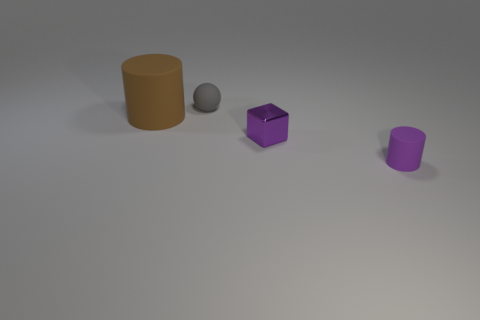How many things are small objects in front of the tiny gray rubber sphere or cylinders on the left side of the tiny metallic object?
Your response must be concise. 3. How many matte cylinders are to the left of the rubber cylinder on the right side of the gray object?
Provide a succinct answer. 1. There is a object that is behind the large brown matte object; does it have the same shape as the purple object behind the tiny purple cylinder?
Offer a terse response. No. What shape is the tiny rubber object that is the same color as the shiny block?
Make the answer very short. Cylinder. Is there a big brown sphere that has the same material as the small purple block?
Keep it short and to the point. No. How many metal things are either tiny gray cubes or purple cubes?
Ensure brevity in your answer.  1. There is a small purple object that is behind the tiny matte object in front of the tiny ball; what is its shape?
Make the answer very short. Cube. Is the number of blocks that are on the right side of the small shiny cube less than the number of tiny purple blocks?
Keep it short and to the point. Yes. The tiny purple rubber object is what shape?
Keep it short and to the point. Cylinder. What size is the rubber cylinder on the left side of the tiny cylinder?
Provide a short and direct response. Large. 